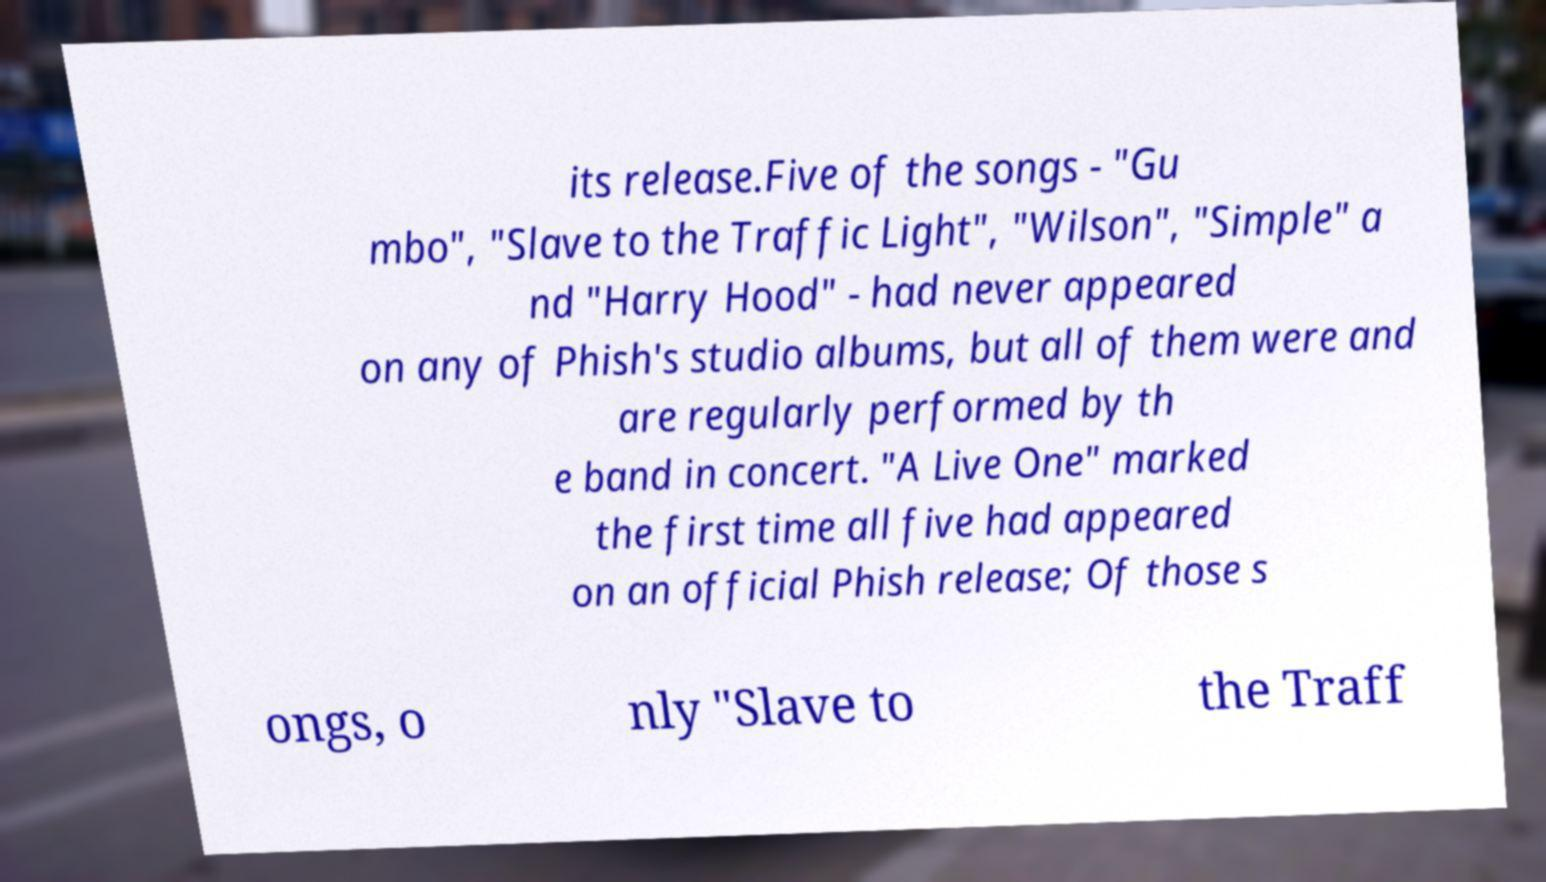Can you accurately transcribe the text from the provided image for me? its release.Five of the songs - "Gu mbo", "Slave to the Traffic Light", "Wilson", "Simple" a nd "Harry Hood" - had never appeared on any of Phish's studio albums, but all of them were and are regularly performed by th e band in concert. "A Live One" marked the first time all five had appeared on an official Phish release; Of those s ongs, o nly "Slave to the Traff 